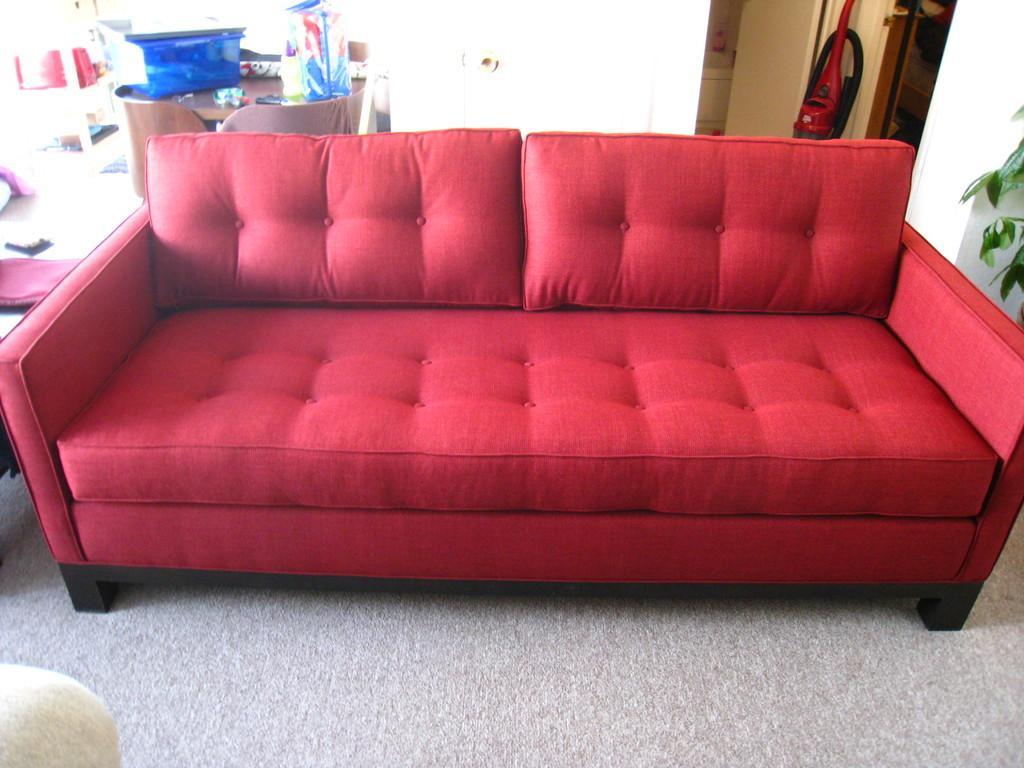How would you summarize this image in a sentence or two? This picture is clicked inside the room. In the middle of the picture, we see a red sofa and behind that, we see a white wall and table on which blue box and cloth are placed. Beside that, we see a red table. 